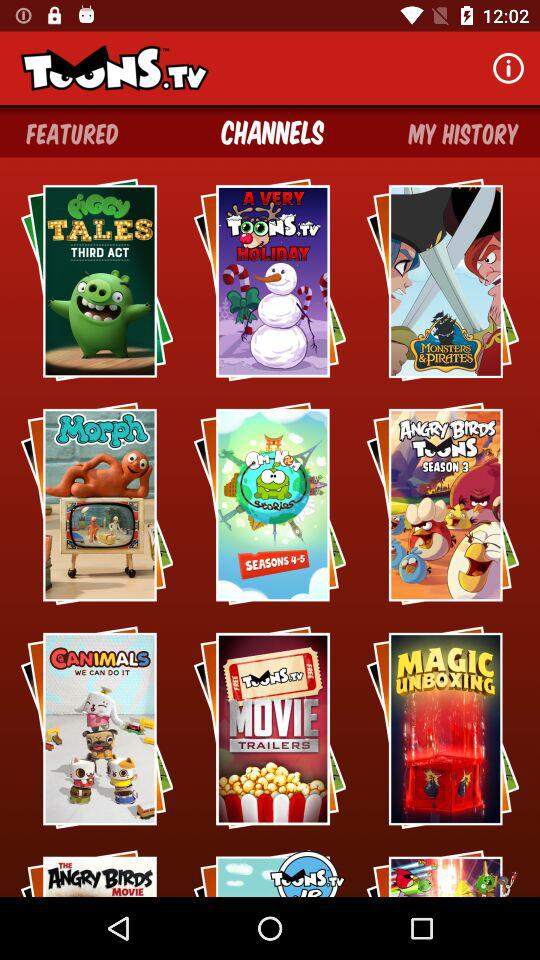What is the selected tab? The selected tab is "CHANNELS". 